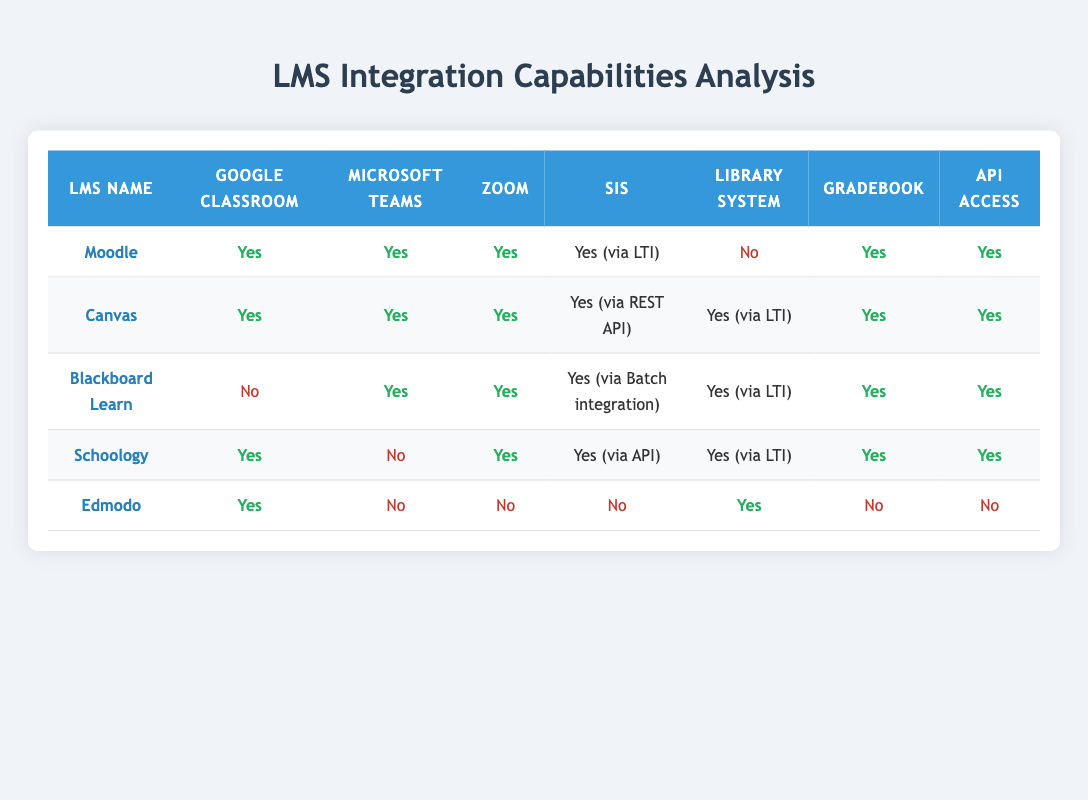What LMS options have integration with Google Classroom? To find the LMS options that integrate with Google Classroom, look for "Yes" in the Google Classroom Integration column. The ones listed are Moodle, Canvas, Schoology, and Edmodo.
Answer: Moodle, Canvas, Schoology, Edmodo Which LMS has the capability to integrate with both Microsoft Teams and Zoom? Check the Microsoft Teams Integration and Zoom Integration columns for "Yes." The LMS options meeting both criteria are Moodle, Canvas, Blackboard Learn, and Schoology.
Answer: Moodle, Canvas, Blackboard Learn, Schoology Does Blackboard Learn support API access? Look for the value in the API Access column for Blackboard Learn. It shows "Yes," indicating that it does support API access.
Answer: Yes How many LMS options do not integrate with the Library System? Count the instances of "No" in the Library System Integration column. Only Moodle and Edmodo show "No," so there are two LMS options.
Answer: 2 Which LMS options have the most integration capabilities? To determine this, count the number of "Yes" responses across each LMS in all integration categories. Canvas has 7 "Yes" responses, making it the highest.
Answer: Canvas Is there any LMS that does not support Zoom integration? Look through the Zoom Integration column for "No." Edmodo shows "No," so it is the only option without Zoom integration.
Answer: Edmodo What is the difference in the number of integrations between Moodle and Canvas? Count the total "Yes" responses for each LMS. Moodle has 6 "Yes," while Canvas has 7 "Yes." The difference is 7 - 6 = 1.
Answer: 1 Can we say that all LMS options support Gradebook integration? Review the Gradebook Integration column for "No." Edmodo shows "No," indicating not all options support Gradebook integration.
Answer: No How many LMS integrate with both Google Classroom and Zoom? Find LMS options with "Yes" in both Google Classroom and Zoom columns. Moodle, Canvas, and Schoology fulfill both conditions, so there are three.
Answer: 3 What percentage of LMS options integrates with Microsoft Teams? There are 5 LMS options in total, and 4 of them integrate with Microsoft Teams. The percentage is (4/5) * 100 = 80%.
Answer: 80% 